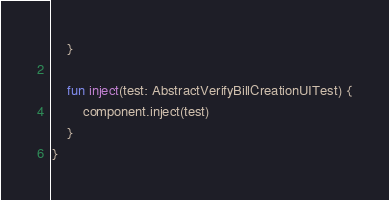Convert code to text. <code><loc_0><loc_0><loc_500><loc_500><_Kotlin_>    }

    fun inject(test: AbstractVerifyBillCreationUITest) {
        component.inject(test)
    }
}
</code> 